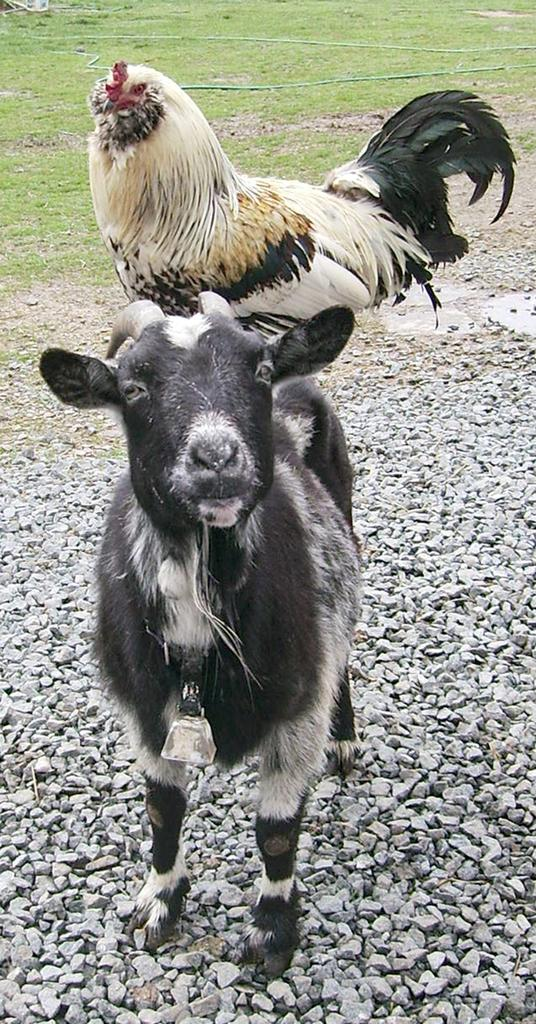What type of animal is in the image, and what colors is it? There is an animal in black and white color in the image. What other creature is present in the image, and what colors is it? There is a bird in brown, white, and black color in the image. What type of terrain is visible in the image? There are small stones and grass visible in the image. What type of humor can be seen in the image? There is no humor present in the image; it features an animal and a bird in a natural setting. Can you tell me how many robins are in the image? There is only one bird in the image, and it is not specified as a robin. --- Facts: 1. There is a person holding a camera in the image. 2. The person is wearing a hat. 3. There is a building in the background of the image. 4. The sky is visible in the image. Absurd Topics: parrot, bicycle, ocean Conversation: What is the person in the image doing? The person in the image is holding a camera. What type of headwear is the person wearing? The person is wearing a hat. What can be seen in the background of the image? There is a building in the background of the image. What is visible at the top of the image? The sky is visible in the image. Reasoning: Let's think step by step in order to produce the conversation. We start by identifying the main subject in the image, which is the person holding a camera. Then, we expand the conversation to include other details about the person, such as the hat they are wearing. Finally, we mention the background and the sky visible in the image. Absurd Question/Answer: Can you tell me how many parrots are sitting on the bicycle in the image? There are no parrots or bicycles present in the image. What type of ocean can be seen in the image? There is no ocean visible in the image; it features a person holding a camera, a building in the background, and the sky. 